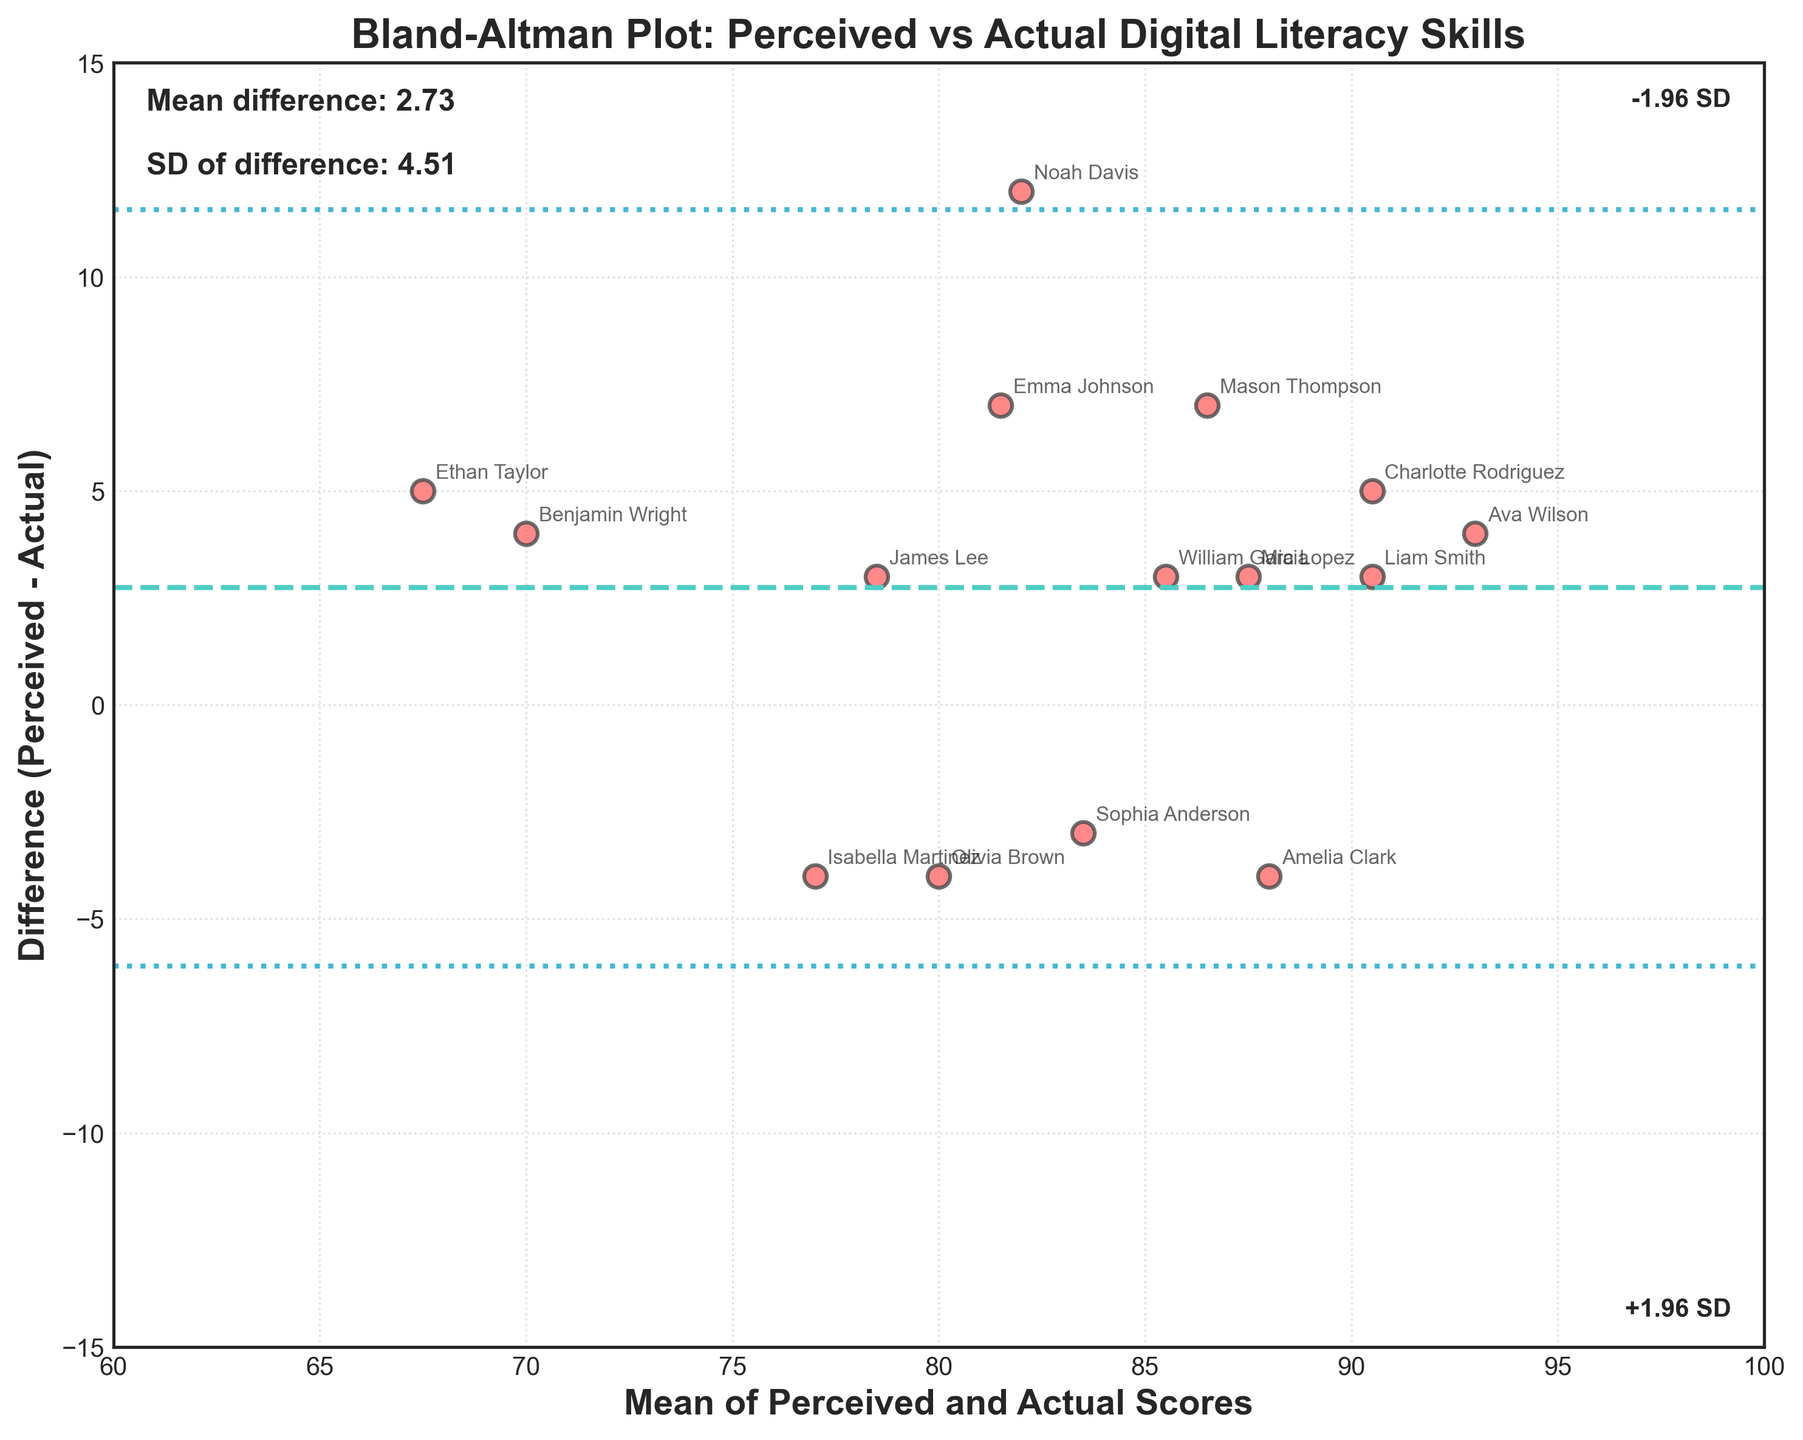What is the title of the plot? The title of the plot is displayed at the top and typically provides an overview of what the plot represents.
Answer: Bland-Altman Plot: Perceived vs Actual Digital Literacy Skills How many data points are plotted? Each data point represents a student and there are clearly labeled around 15 points on the plot.
Answer: 15 What is the mean difference between perceived and actual scores? The mean difference is usually marked on the plot often annotated and represented by a horizontal dashed line.
Answer: Approximately 2.93 Which student has the highest perceived score? The highest perceived score point can be identified by looking at the annotation on the top-right section of the plot. A student with the highest perceived score is labeled.
Answer: Ava Wilson What does the horizontal dashed line near the middle of the plot represent? This horizontal line represents the mean difference between perceived and actual scores.
Answer: Mean difference What is the range of the mean of perceived and actual scores on the x-axis? The x-axis range is displayed numerically along the axis, representing the range of average scores between 60 to around 100.
Answer: 60 to 100 Which two students have the greatest difference between perceived and actual scores? Look for the data points furthest from the mean difference line vertically; these are labeled with students' names.
Answer: Noah Davis and Ethan Taylor What does the dotted line above (or below) the mean difference line signify? The dotted lines above and below signify the limits of agreement, which are typically 1.96 standard deviations away from the mean.
Answer: +1.96 SD and -1.96 SD Who is the student closest to the overall mean difference line? The data point that lies closest to the horizontal mean difference line is considered. The student label near this point will answer the question.
Answer: Amelia Clark Are the average digital literacy scores generally higher for perceived or actual performance? By looking at the overall distribution of points above or below the mean line, you can assess which scores tend to be higher. If most points are above the mean line, perceived scores are generally higher, otherwise, actual scores are.
Answer: Perceived scores are generally higher 